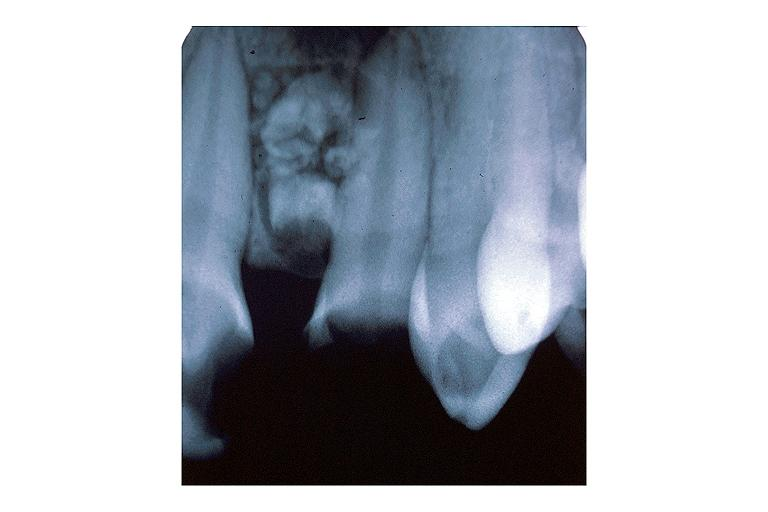s oral present?
Answer the question using a single word or phrase. Yes 